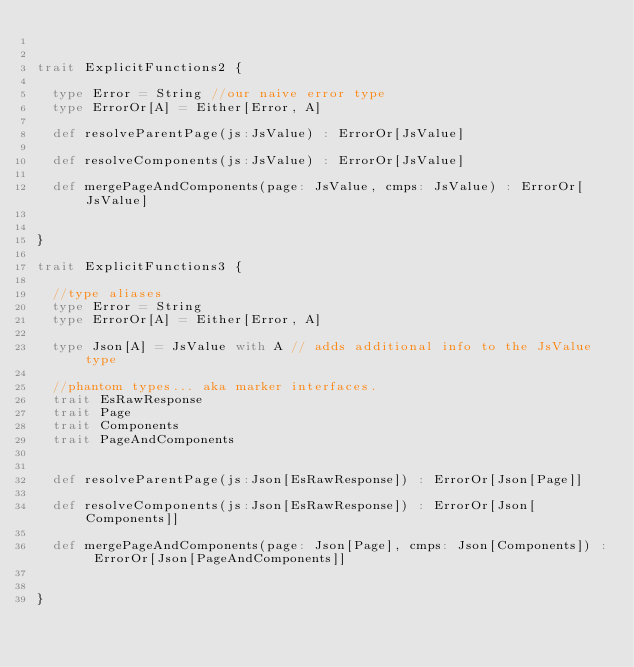<code> <loc_0><loc_0><loc_500><loc_500><_Scala_>

trait ExplicitFunctions2 {

  type Error = String //our naive error type
  type ErrorOr[A] = Either[Error, A]

  def resolveParentPage(js:JsValue) : ErrorOr[JsValue]

  def resolveComponents(js:JsValue) : ErrorOr[JsValue]

  def mergePageAndComponents(page: JsValue, cmps: JsValue) : ErrorOr[JsValue]


}

trait ExplicitFunctions3 {

  //type aliases
  type Error = String
  type ErrorOr[A] = Either[Error, A]

  type Json[A] = JsValue with A // adds additional info to the JsValue type

  //phantom types... aka marker interfaces.
  trait EsRawResponse
  trait Page
  trait Components
  trait PageAndComponents


  def resolveParentPage(js:Json[EsRawResponse]) : ErrorOr[Json[Page]]

  def resolveComponents(js:Json[EsRawResponse]) : ErrorOr[Json[Components]]

  def mergePageAndComponents(page: Json[Page], cmps: Json[Components]) : ErrorOr[Json[PageAndComponents]]


}</code> 